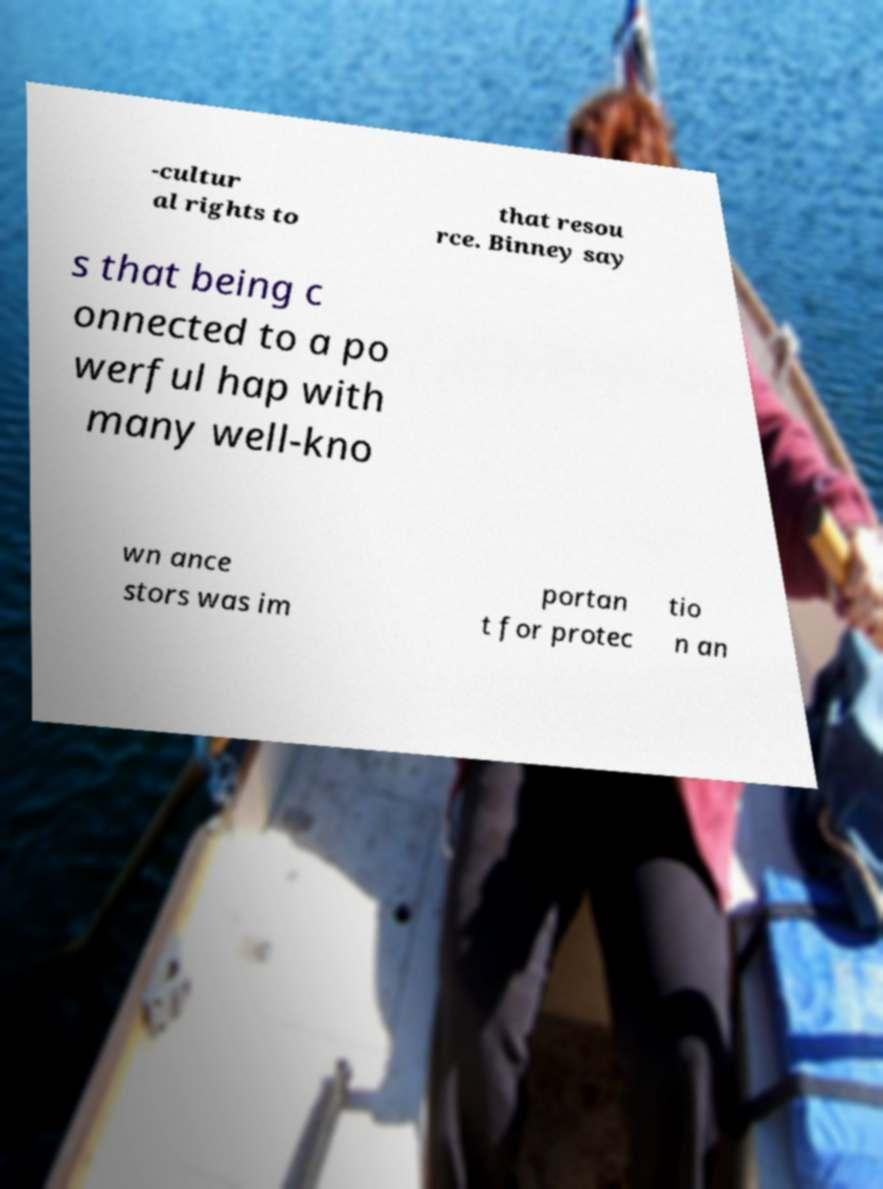Can you accurately transcribe the text from the provided image for me? -cultur al rights to that resou rce. Binney say s that being c onnected to a po werful hap with many well-kno wn ance stors was im portan t for protec tio n an 